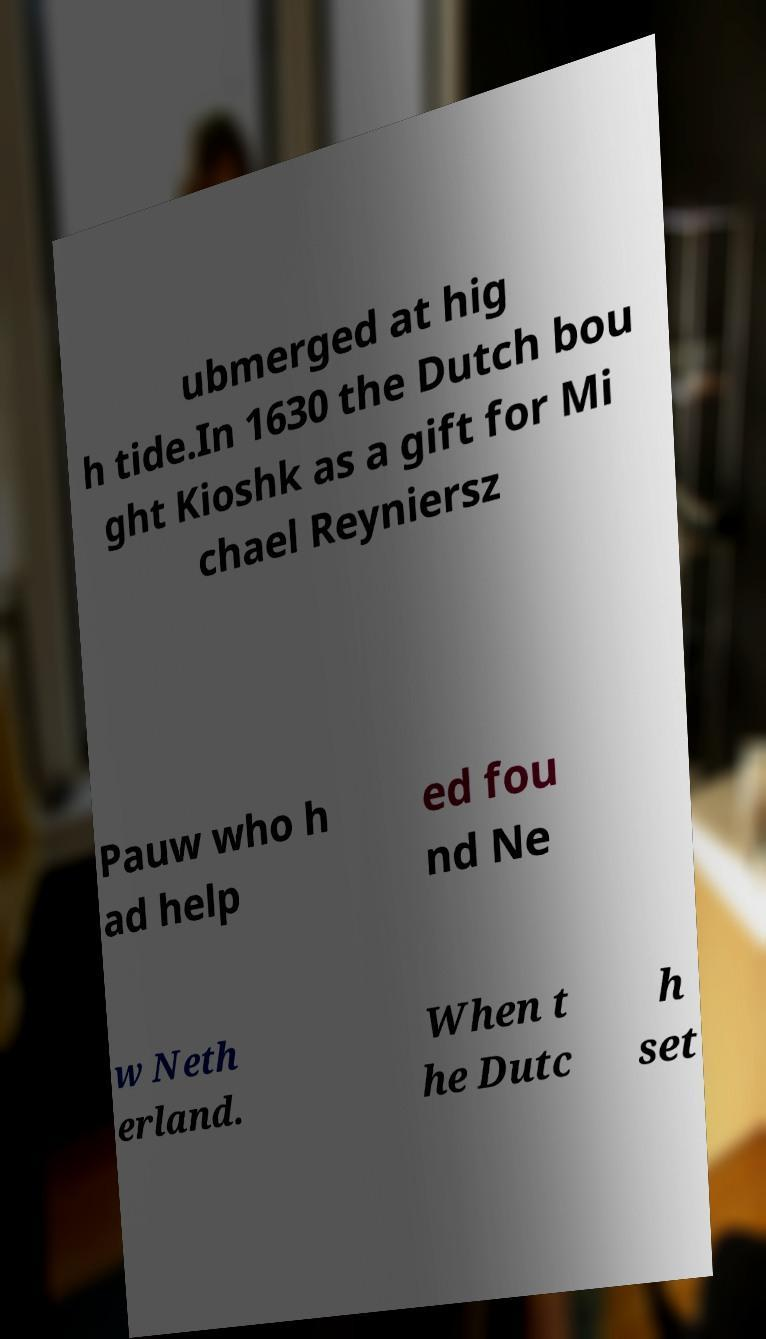Can you accurately transcribe the text from the provided image for me? ubmerged at hig h tide.In 1630 the Dutch bou ght Kioshk as a gift for Mi chael Reyniersz Pauw who h ad help ed fou nd Ne w Neth erland. When t he Dutc h set 